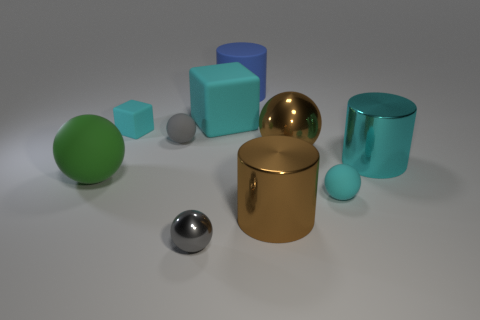Does the tiny cyan thing on the right side of the small metal ball have the same shape as the gray matte object behind the big cyan metal thing?
Make the answer very short. Yes. The cyan rubber thing that is the same size as the cyan matte sphere is what shape?
Provide a succinct answer. Cube. How many matte things are large yellow spheres or blocks?
Your answer should be very brief. 2. Do the tiny cyan thing behind the large cyan shiny thing and the big cyan object that is on the left side of the blue cylinder have the same material?
Your answer should be very brief. Yes. There is a large block that is made of the same material as the large green ball; what color is it?
Give a very brief answer. Cyan. Are there more large metallic cylinders behind the small cyan ball than tiny shiny balls that are behind the blue cylinder?
Your answer should be compact. Yes. Are there any small purple shiny cylinders?
Offer a terse response. No. There is a tiny object that is the same color as the tiny shiny sphere; what is it made of?
Provide a short and direct response. Rubber. What number of things are either green matte spheres or spheres?
Provide a short and direct response. 5. Are there any tiny rubber spheres of the same color as the small shiny object?
Your answer should be very brief. Yes. 